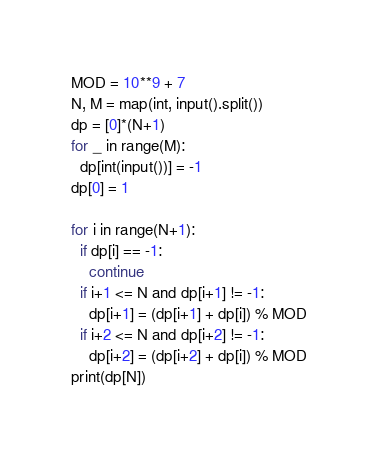Convert code to text. <code><loc_0><loc_0><loc_500><loc_500><_Python_>MOD = 10**9 + 7
N, M = map(int, input().split())
dp = [0]*(N+1)
for _ in range(M):
  dp[int(input())] = -1
dp[0] = 1

for i in range(N+1):
  if dp[i] == -1:
    continue
  if i+1 <= N and dp[i+1] != -1:
    dp[i+1] = (dp[i+1] + dp[i]) % MOD
  if i+2 <= N and dp[i+2] != -1:
    dp[i+2] = (dp[i+2] + dp[i]) % MOD
print(dp[N])</code> 